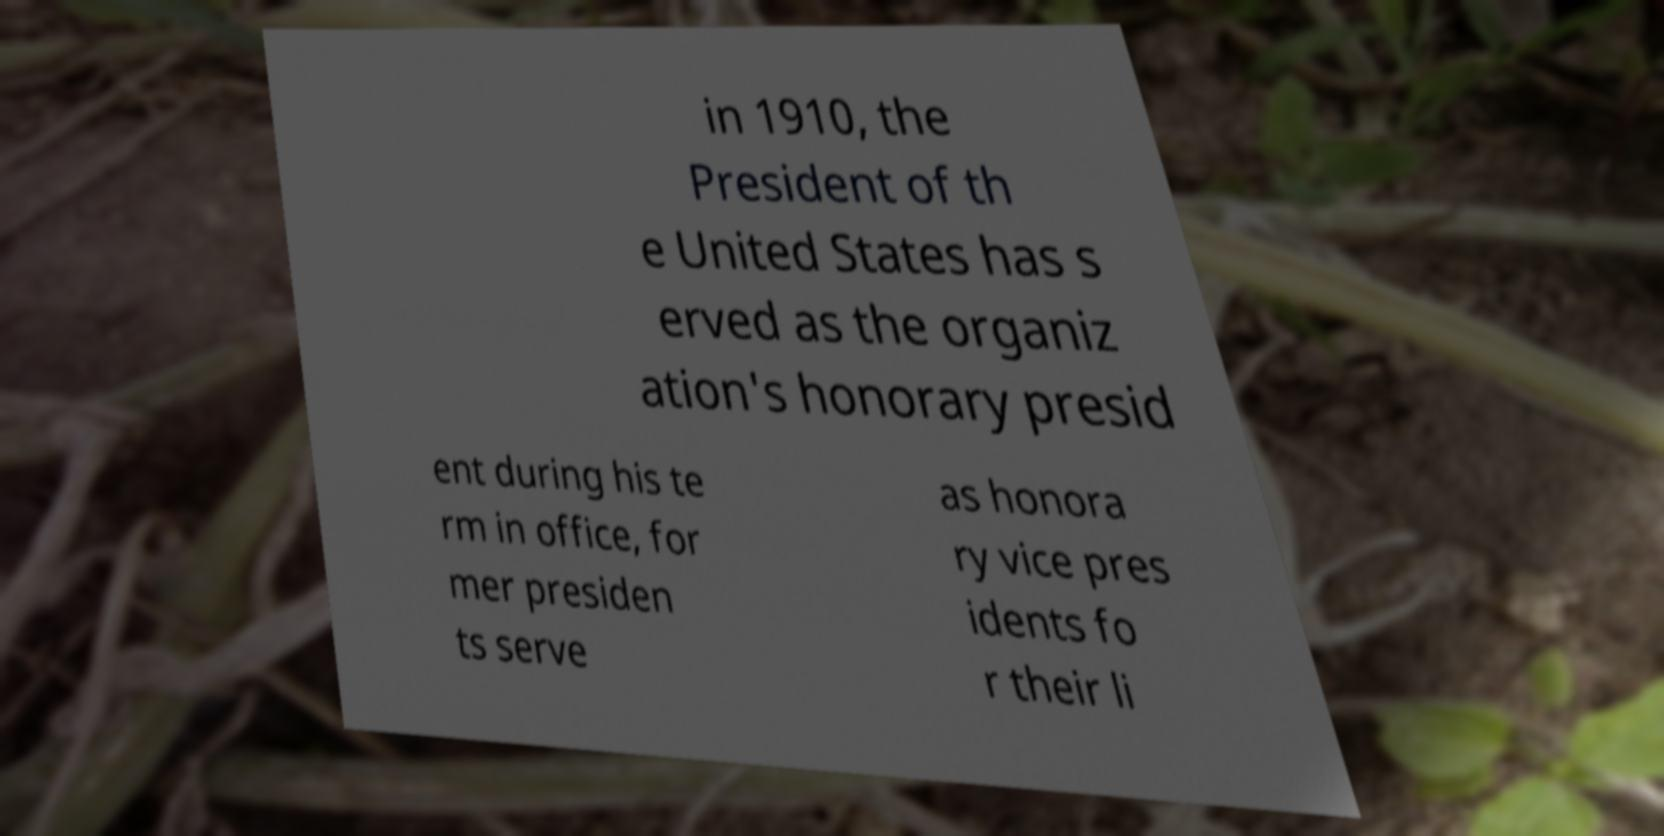What messages or text are displayed in this image? I need them in a readable, typed format. in 1910, the President of th e United States has s erved as the organiz ation's honorary presid ent during his te rm in office, for mer presiden ts serve as honora ry vice pres idents fo r their li 